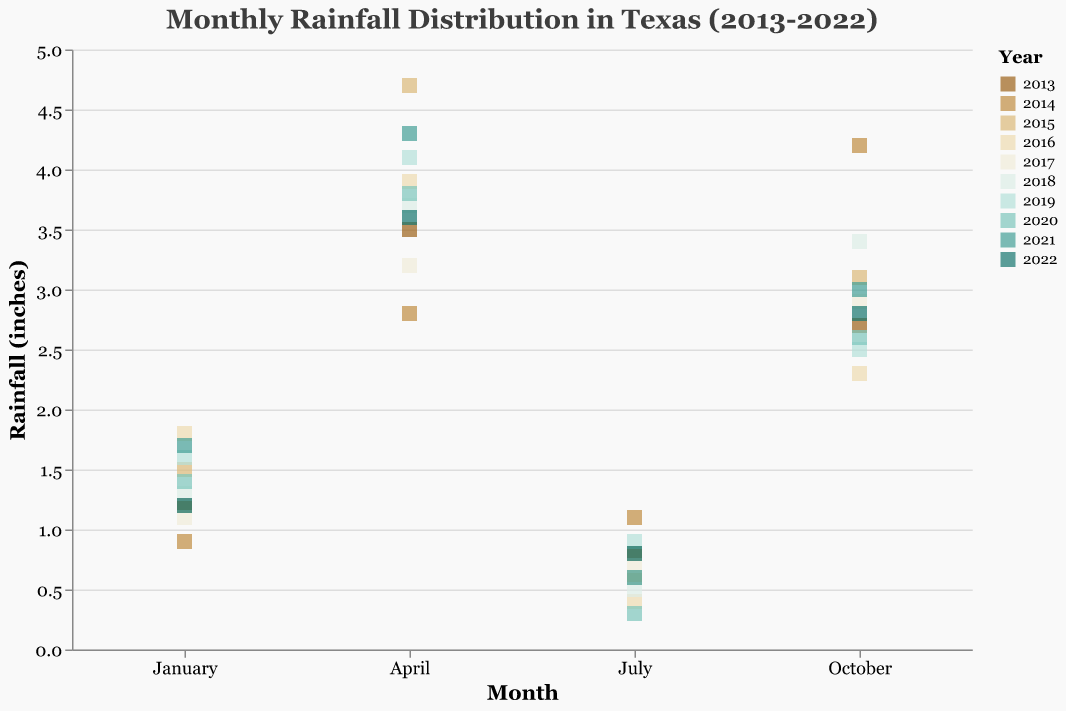What's the title of the figure? The title is located at the top of the figure and is written in the largest font size. It provides a summary of what the figure represents.
Answer: Monthly Rainfall Distribution in Texas (2013-2022) Which month has the highest average rainfall? Visually compare the vertical positions of points for each month on the y-axis, which represents rainfall in inches, and note which month has the generally higher positions.
Answer: April What's the range of rainfall values observed in July over the past decade? Observe the vertical spread of points under July. The lowest point is at 0.3 inches, and the highest point is at 1.1 inches.
Answer: 0.3 to 1.1 inches Which year had the highest rainfall in October? Look at the highest point under October and note its color, which represents the year (this can be cross-checked with the legend).
Answer: 2014 In which year did January have the lowest rainfall? Identify the lowest point vertically under January and note its color, cross-referencing it with the legend.
Answer: 2014 How does the rainfall distribution in July compare to April for the years 2015 and 2016? Compare the heights of points for July and April for the years 2015 and 2016 by looking at their positions on the y-axis and the corresponding colors in the legend.
Answer: July has less rainfall than April for both years What is the median rainfall for October? The median requires sorting the values and finding the middle one. For October, sort: 2.3, 2.5, 2.6, 2.7, 2.8, 2.9, 3.0, 3.0, 3.1, 3.4, 4.2. The median is the middle value (2.9).
Answer: 2.9 inches Compare the range of rainfall in April to October. Which month has a wider range? Compare the vertical span of points for April and October. April ranges from 2.8 to 4.7 (range = 1.9), October ranges from 2.3 to 4.2 (range = 1.9). Thus, both have the same range.
Answer: April and October have the same range In which month can we observe the highest variation in rainfall over the years? Look for the month with the widest vertical spread of points, indicating high variation. April has points from 2.8 to 4.7 inches.
Answer: April What's the average rainfall in January for the past decade? Sum the rainfall values for January for each year and divide by the number of data points. The sum is 1.2 + 0.9 + 1.5 + 1.8 + 1.1 + 1.3 + 1.6 + 1.4 + 1.7 + 1.2 = 13.7. Average=13.7/10=1.37 inches.
Answer: 1.37 inches 